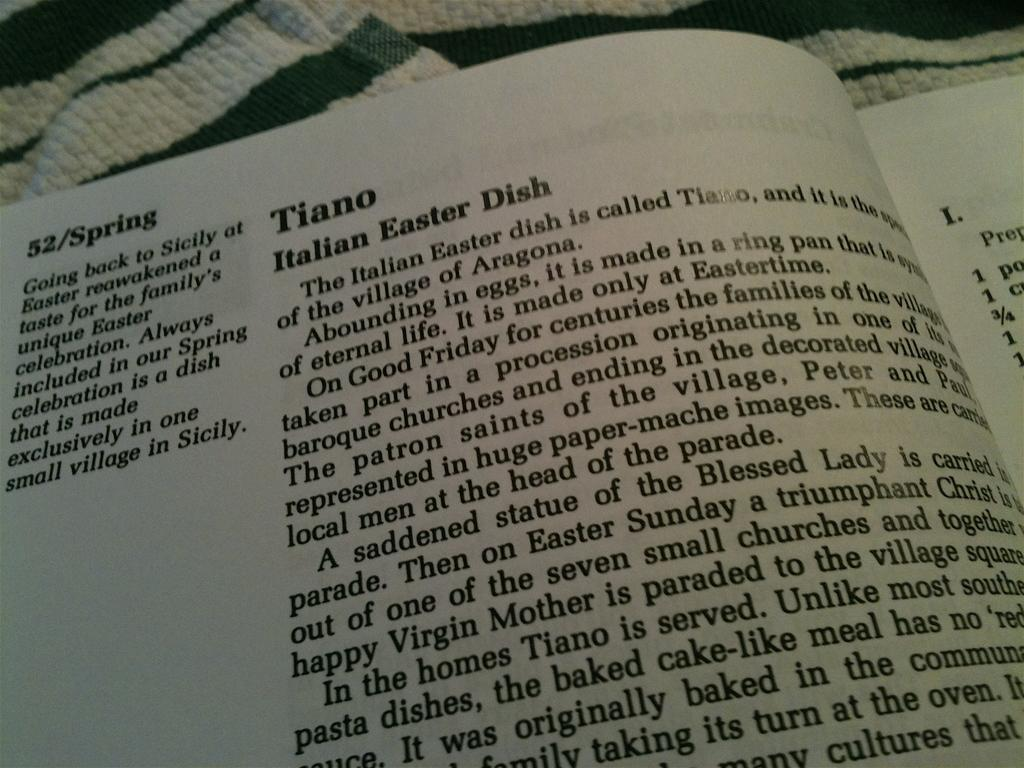<image>
Write a terse but informative summary of the picture. Book consisting of Tiano Italian Easter Dish on 52/Spring. 